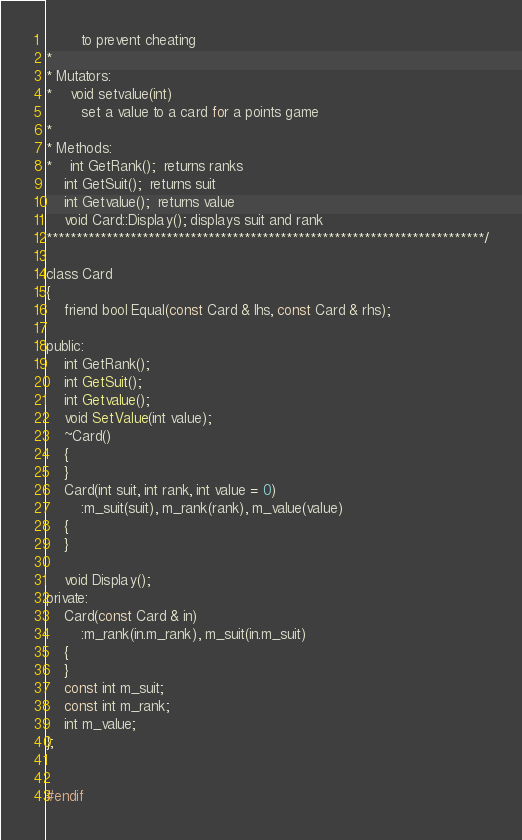<code> <loc_0><loc_0><loc_500><loc_500><_C_>		to prevent cheating
*
* Mutators:
*	void setvalue(int)
		set a value to a card for a points game
*
* Methods:		
*	int GetRank();  returns ranks
	int GetSuit();  returns suit
	int Getvalue();  returns value
	void Card::Display(); displays suit and rank
*************************************************************************/

class Card
{
	friend bool Equal(const Card & lhs, const Card & rhs);

public:
	int GetRank();
	int GetSuit();
	int Getvalue();
	void SetValue(int value);
	~Card()
	{
	}
	Card(int suit, int rank, int value = 0)
		:m_suit(suit), m_rank(rank), m_value(value)
	{
	}

	void Display();
private:
	Card(const Card & in)
		:m_rank(in.m_rank), m_suit(in.m_suit)
	{
	}
	const int m_suit;
	const int m_rank;
	int m_value;
};


#endif</code> 